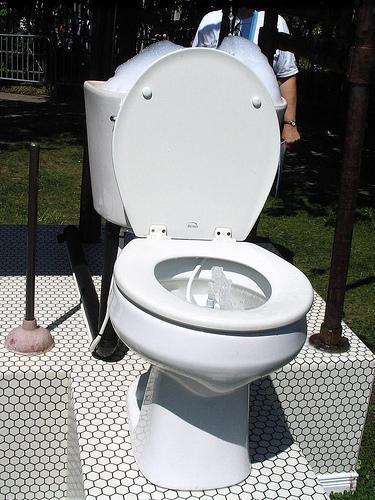How many plungers are pictureD?
Give a very brief answer. 1. 